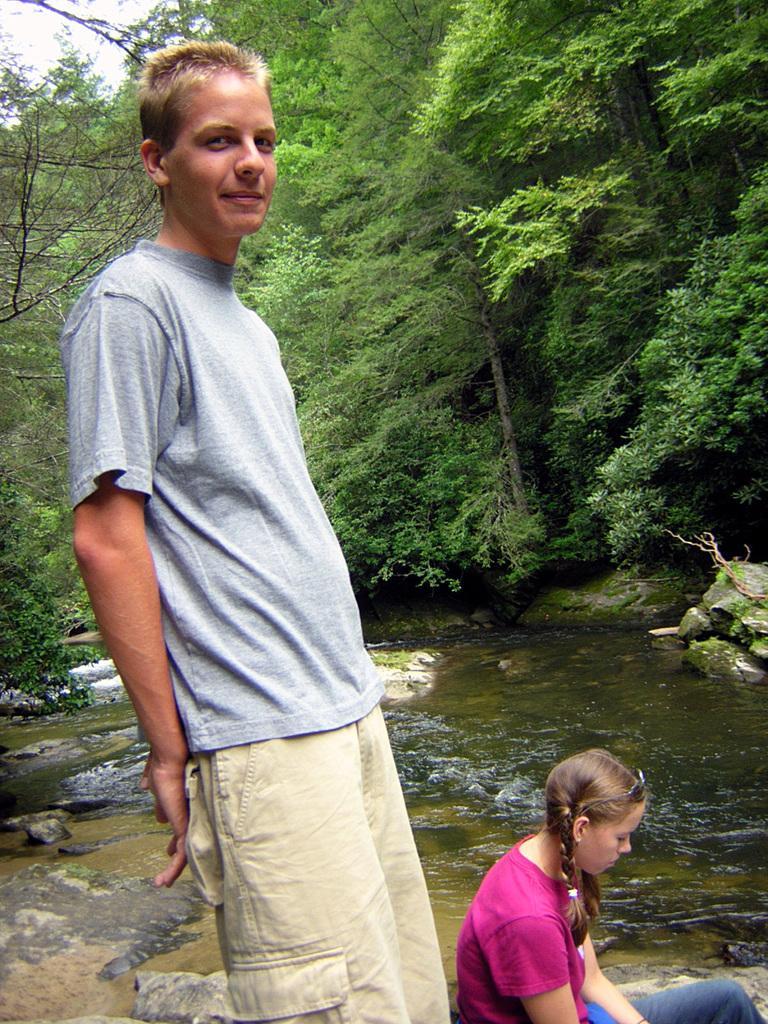Could you give a brief overview of what you see in this image? In this picture we can see a man standing, smiling and beside him we can see a girl, stones, water and in the background we can see trees. 